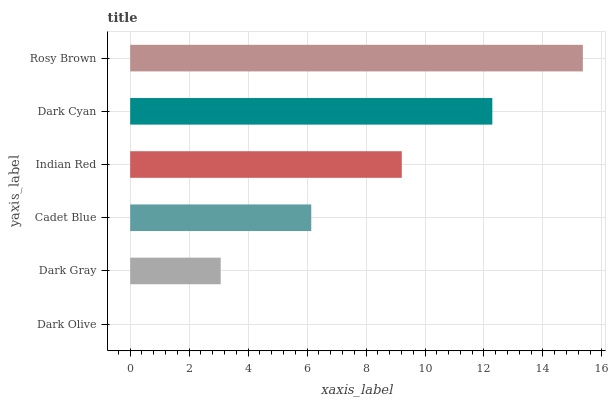Is Dark Olive the minimum?
Answer yes or no. Yes. Is Rosy Brown the maximum?
Answer yes or no. Yes. Is Dark Gray the minimum?
Answer yes or no. No. Is Dark Gray the maximum?
Answer yes or no. No. Is Dark Gray greater than Dark Olive?
Answer yes or no. Yes. Is Dark Olive less than Dark Gray?
Answer yes or no. Yes. Is Dark Olive greater than Dark Gray?
Answer yes or no. No. Is Dark Gray less than Dark Olive?
Answer yes or no. No. Is Indian Red the high median?
Answer yes or no. Yes. Is Cadet Blue the low median?
Answer yes or no. Yes. Is Rosy Brown the high median?
Answer yes or no. No. Is Dark Gray the low median?
Answer yes or no. No. 